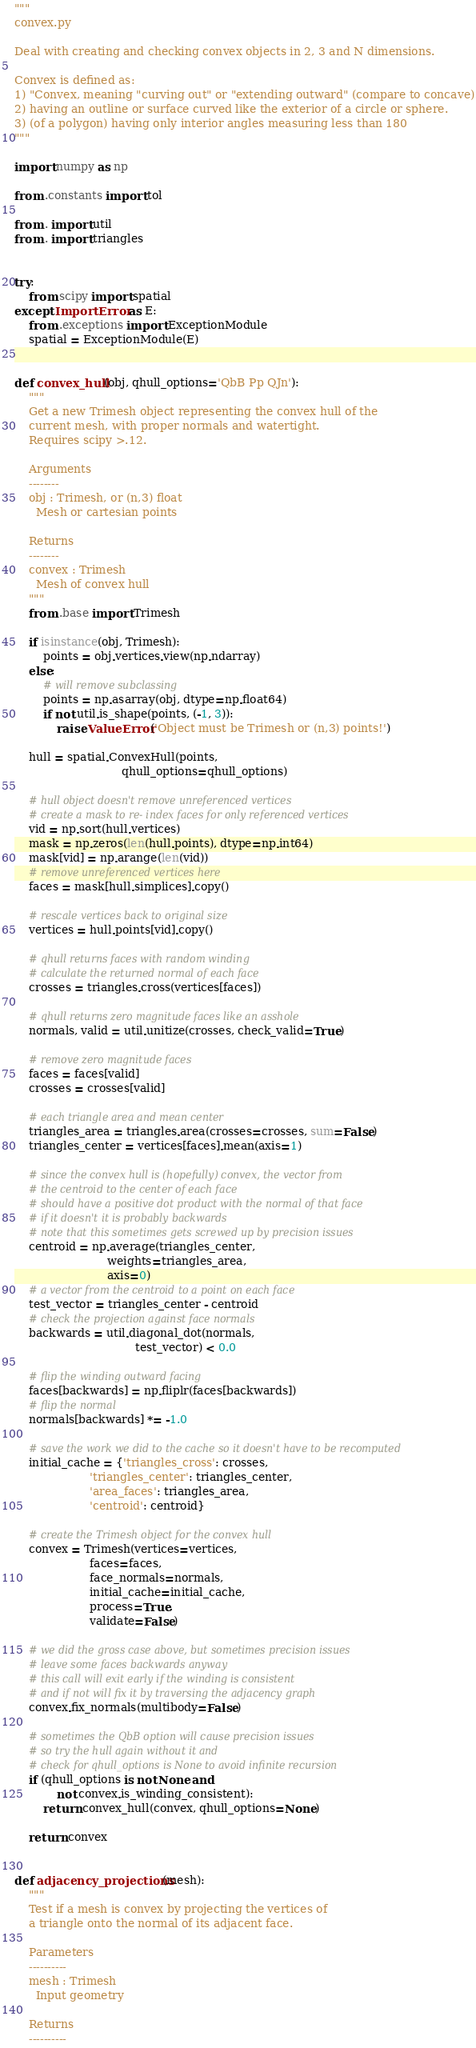Convert code to text. <code><loc_0><loc_0><loc_500><loc_500><_Python_>"""
convex.py

Deal with creating and checking convex objects in 2, 3 and N dimensions.

Convex is defined as:
1) "Convex, meaning "curving out" or "extending outward" (compare to concave)
2) having an outline or surface curved like the exterior of a circle or sphere.
3) (of a polygon) having only interior angles measuring less than 180
"""

import numpy as np

from .constants import tol

from . import util
from . import triangles


try:
    from scipy import spatial
except ImportError as E:
    from .exceptions import ExceptionModule
    spatial = ExceptionModule(E)


def convex_hull(obj, qhull_options='QbB Pp QJn'):
    """
    Get a new Trimesh object representing the convex hull of the
    current mesh, with proper normals and watertight.
    Requires scipy >.12.

    Arguments
    --------
    obj : Trimesh, or (n,3) float
      Mesh or cartesian points

    Returns
    --------
    convex : Trimesh
      Mesh of convex hull
    """
    from .base import Trimesh

    if isinstance(obj, Trimesh):
        points = obj.vertices.view(np.ndarray)
    else:
        # will remove subclassing
        points = np.asarray(obj, dtype=np.float64)
        if not util.is_shape(points, (-1, 3)):
            raise ValueError('Object must be Trimesh or (n,3) points!')

    hull = spatial.ConvexHull(points,
                              qhull_options=qhull_options)

    # hull object doesn't remove unreferenced vertices
    # create a mask to re- index faces for only referenced vertices
    vid = np.sort(hull.vertices)
    mask = np.zeros(len(hull.points), dtype=np.int64)
    mask[vid] = np.arange(len(vid))
    # remove unreferenced vertices here
    faces = mask[hull.simplices].copy()

    # rescale vertices back to original size
    vertices = hull.points[vid].copy()

    # qhull returns faces with random winding
    # calculate the returned normal of each face
    crosses = triangles.cross(vertices[faces])

    # qhull returns zero magnitude faces like an asshole
    normals, valid = util.unitize(crosses, check_valid=True)

    # remove zero magnitude faces
    faces = faces[valid]
    crosses = crosses[valid]

    # each triangle area and mean center
    triangles_area = triangles.area(crosses=crosses, sum=False)
    triangles_center = vertices[faces].mean(axis=1)

    # since the convex hull is (hopefully) convex, the vector from
    # the centroid to the center of each face
    # should have a positive dot product with the normal of that face
    # if it doesn't it is probably backwards
    # note that this sometimes gets screwed up by precision issues
    centroid = np.average(triangles_center,
                          weights=triangles_area,
                          axis=0)
    # a vector from the centroid to a point on each face
    test_vector = triangles_center - centroid
    # check the projection against face normals
    backwards = util.diagonal_dot(normals,
                                  test_vector) < 0.0

    # flip the winding outward facing
    faces[backwards] = np.fliplr(faces[backwards])
    # flip the normal
    normals[backwards] *= -1.0

    # save the work we did to the cache so it doesn't have to be recomputed
    initial_cache = {'triangles_cross': crosses,
                     'triangles_center': triangles_center,
                     'area_faces': triangles_area,
                     'centroid': centroid}

    # create the Trimesh object for the convex hull
    convex = Trimesh(vertices=vertices,
                     faces=faces,
                     face_normals=normals,
                     initial_cache=initial_cache,
                     process=True,
                     validate=False)

    # we did the gross case above, but sometimes precision issues
    # leave some faces backwards anyway
    # this call will exit early if the winding is consistent
    # and if not will fix it by traversing the adjacency graph
    convex.fix_normals(multibody=False)

    # sometimes the QbB option will cause precision issues
    # so try the hull again without it and
    # check for qhull_options is None to avoid infinite recursion
    if (qhull_options is not None and
            not convex.is_winding_consistent):
        return convex_hull(convex, qhull_options=None)

    return convex


def adjacency_projections(mesh):
    """
    Test if a mesh is convex by projecting the vertices of
    a triangle onto the normal of its adjacent face.

    Parameters
    ----------
    mesh : Trimesh
      Input geometry

    Returns
    ----------</code> 